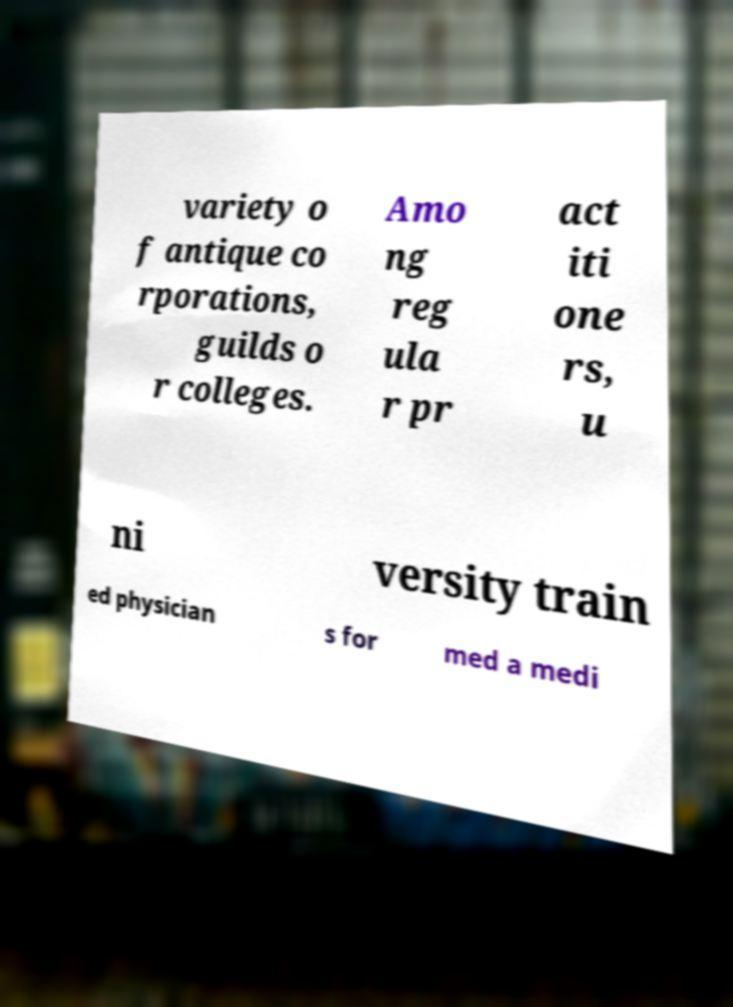Could you extract and type out the text from this image? variety o f antique co rporations, guilds o r colleges. Amo ng reg ula r pr act iti one rs, u ni versity train ed physician s for med a medi 